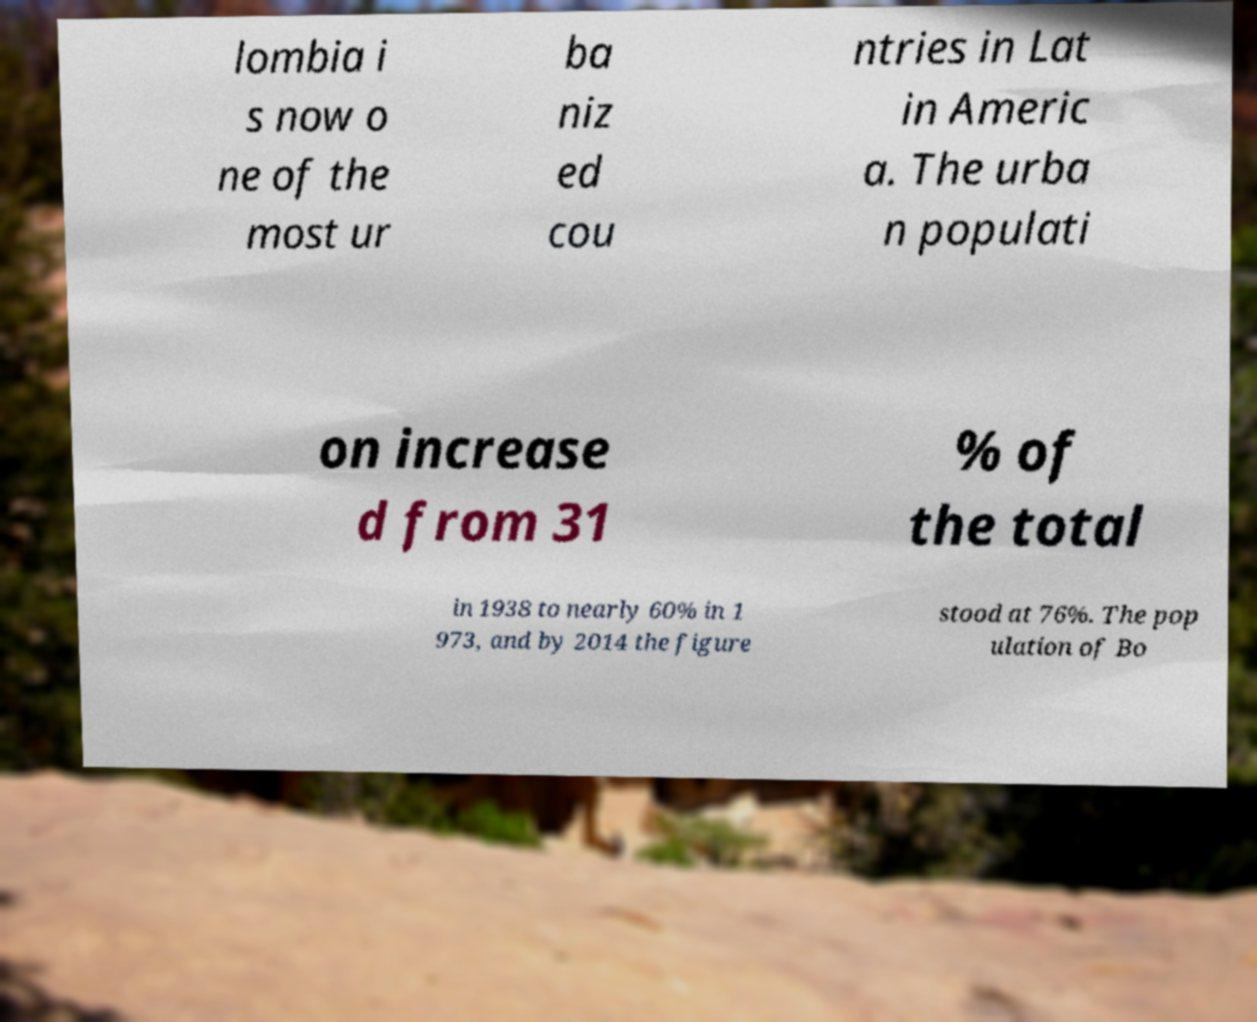I need the written content from this picture converted into text. Can you do that? lombia i s now o ne of the most ur ba niz ed cou ntries in Lat in Americ a. The urba n populati on increase d from 31 % of the total in 1938 to nearly 60% in 1 973, and by 2014 the figure stood at 76%. The pop ulation of Bo 